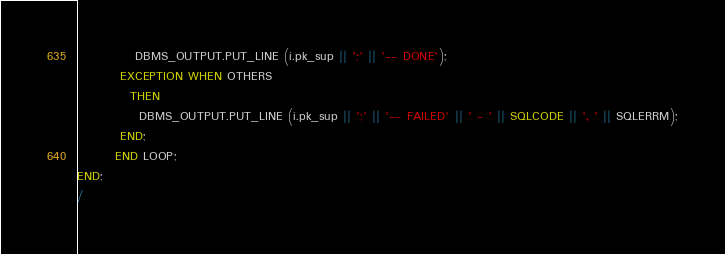<code> <loc_0><loc_0><loc_500><loc_500><_SQL_>            DBMS_OUTPUT.PUT_LINE (i.pk_sup || ';' || '-- DONE');
         EXCEPTION WHEN OTHERS
           THEN
             DBMS_OUTPUT.PUT_LINE (i.pk_sup || ';' || '-- FAILED' || ' - ' || SQLCODE || ', ' || SQLERRM);
         END;
        END LOOP;
END;
/</code> 